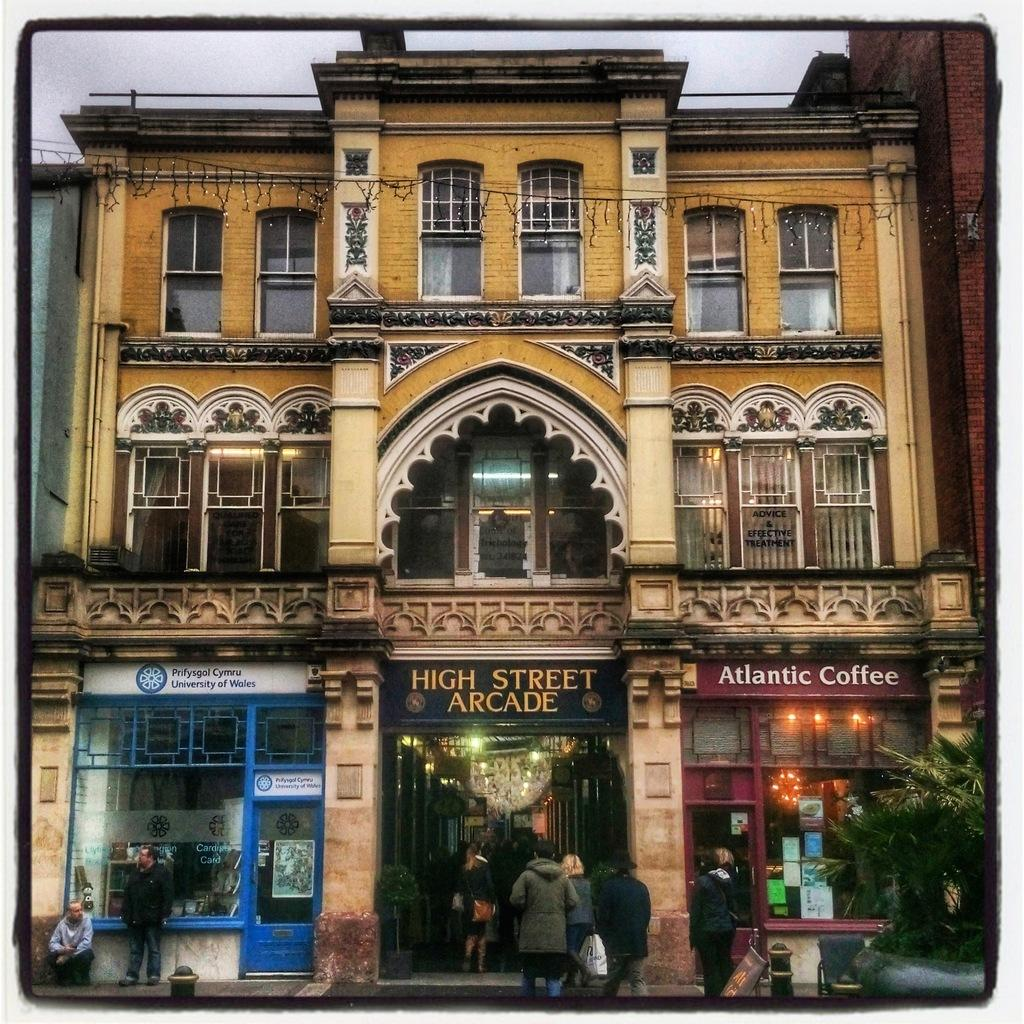What is the main structure in the center of the image? There is a building in the center of the image. Who or what can be seen at the bottom of the image? People are visible at the bottom of the image. What type of establishments are located at the bottom of the image? There are stores at the bottom of the image. What type of vegetation is on the right side of the image? There is a tree on the right side of the image. What is visible at the top of the image? The sky is visible at the top of the image. What type of knowledge can be gained from the books in the image? There are no books present in the image, so no knowledge can be gained from them. 